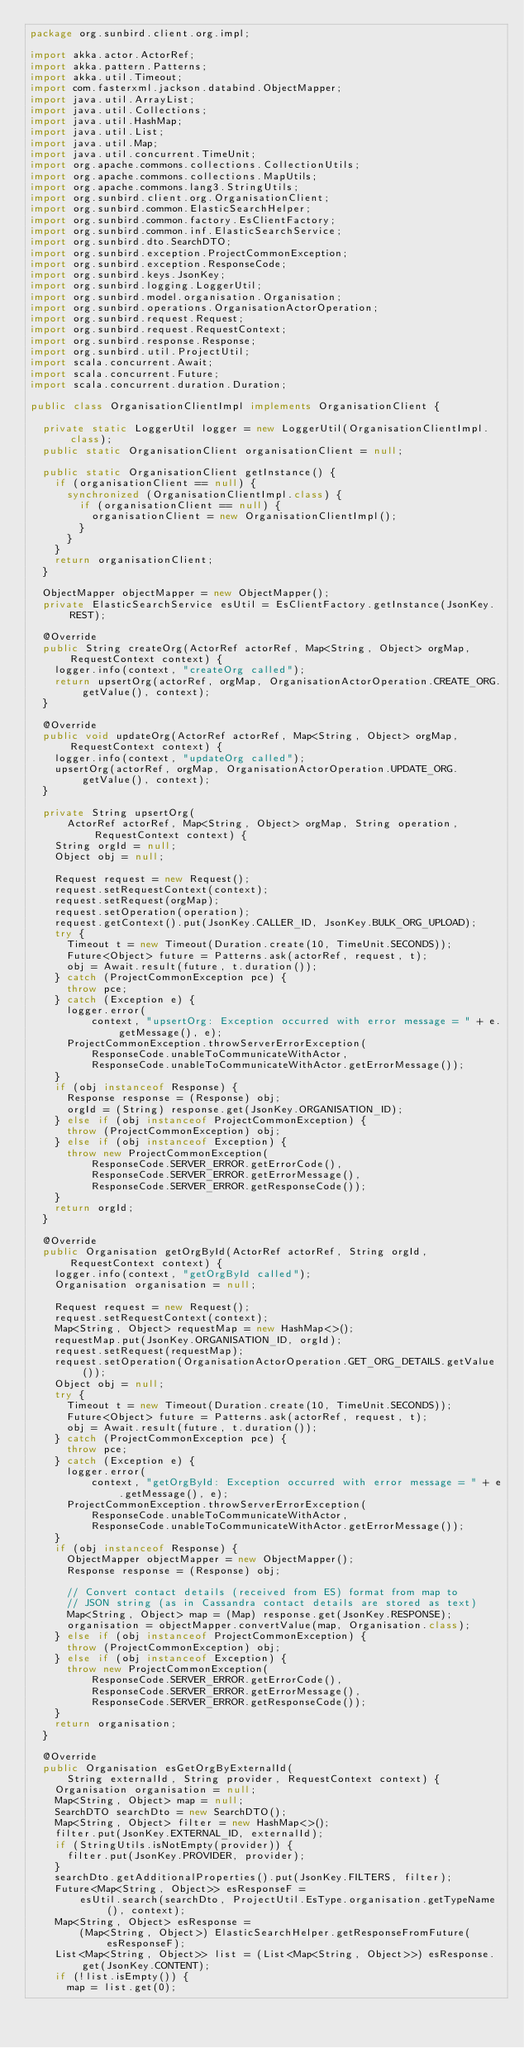<code> <loc_0><loc_0><loc_500><loc_500><_Java_>package org.sunbird.client.org.impl;

import akka.actor.ActorRef;
import akka.pattern.Patterns;
import akka.util.Timeout;
import com.fasterxml.jackson.databind.ObjectMapper;
import java.util.ArrayList;
import java.util.Collections;
import java.util.HashMap;
import java.util.List;
import java.util.Map;
import java.util.concurrent.TimeUnit;
import org.apache.commons.collections.CollectionUtils;
import org.apache.commons.collections.MapUtils;
import org.apache.commons.lang3.StringUtils;
import org.sunbird.client.org.OrganisationClient;
import org.sunbird.common.ElasticSearchHelper;
import org.sunbird.common.factory.EsClientFactory;
import org.sunbird.common.inf.ElasticSearchService;
import org.sunbird.dto.SearchDTO;
import org.sunbird.exception.ProjectCommonException;
import org.sunbird.exception.ResponseCode;
import org.sunbird.keys.JsonKey;
import org.sunbird.logging.LoggerUtil;
import org.sunbird.model.organisation.Organisation;
import org.sunbird.operations.OrganisationActorOperation;
import org.sunbird.request.Request;
import org.sunbird.request.RequestContext;
import org.sunbird.response.Response;
import org.sunbird.util.ProjectUtil;
import scala.concurrent.Await;
import scala.concurrent.Future;
import scala.concurrent.duration.Duration;

public class OrganisationClientImpl implements OrganisationClient {

  private static LoggerUtil logger = new LoggerUtil(OrganisationClientImpl.class);
  public static OrganisationClient organisationClient = null;

  public static OrganisationClient getInstance() {
    if (organisationClient == null) {
      synchronized (OrganisationClientImpl.class) {
        if (organisationClient == null) {
          organisationClient = new OrganisationClientImpl();
        }
      }
    }
    return organisationClient;
  }

  ObjectMapper objectMapper = new ObjectMapper();
  private ElasticSearchService esUtil = EsClientFactory.getInstance(JsonKey.REST);

  @Override
  public String createOrg(ActorRef actorRef, Map<String, Object> orgMap, RequestContext context) {
    logger.info(context, "createOrg called");
    return upsertOrg(actorRef, orgMap, OrganisationActorOperation.CREATE_ORG.getValue(), context);
  }

  @Override
  public void updateOrg(ActorRef actorRef, Map<String, Object> orgMap, RequestContext context) {
    logger.info(context, "updateOrg called");
    upsertOrg(actorRef, orgMap, OrganisationActorOperation.UPDATE_ORG.getValue(), context);
  }

  private String upsertOrg(
      ActorRef actorRef, Map<String, Object> orgMap, String operation, RequestContext context) {
    String orgId = null;
    Object obj = null;

    Request request = new Request();
    request.setRequestContext(context);
    request.setRequest(orgMap);
    request.setOperation(operation);
    request.getContext().put(JsonKey.CALLER_ID, JsonKey.BULK_ORG_UPLOAD);
    try {
      Timeout t = new Timeout(Duration.create(10, TimeUnit.SECONDS));
      Future<Object> future = Patterns.ask(actorRef, request, t);
      obj = Await.result(future, t.duration());
    } catch (ProjectCommonException pce) {
      throw pce;
    } catch (Exception e) {
      logger.error(
          context, "upsertOrg: Exception occurred with error message = " + e.getMessage(), e);
      ProjectCommonException.throwServerErrorException(
          ResponseCode.unableToCommunicateWithActor,
          ResponseCode.unableToCommunicateWithActor.getErrorMessage());
    }
    if (obj instanceof Response) {
      Response response = (Response) obj;
      orgId = (String) response.get(JsonKey.ORGANISATION_ID);
    } else if (obj instanceof ProjectCommonException) {
      throw (ProjectCommonException) obj;
    } else if (obj instanceof Exception) {
      throw new ProjectCommonException(
          ResponseCode.SERVER_ERROR.getErrorCode(),
          ResponseCode.SERVER_ERROR.getErrorMessage(),
          ResponseCode.SERVER_ERROR.getResponseCode());
    }
    return orgId;
  }

  @Override
  public Organisation getOrgById(ActorRef actorRef, String orgId, RequestContext context) {
    logger.info(context, "getOrgById called");
    Organisation organisation = null;

    Request request = new Request();
    request.setRequestContext(context);
    Map<String, Object> requestMap = new HashMap<>();
    requestMap.put(JsonKey.ORGANISATION_ID, orgId);
    request.setRequest(requestMap);
    request.setOperation(OrganisationActorOperation.GET_ORG_DETAILS.getValue());
    Object obj = null;
    try {
      Timeout t = new Timeout(Duration.create(10, TimeUnit.SECONDS));
      Future<Object> future = Patterns.ask(actorRef, request, t);
      obj = Await.result(future, t.duration());
    } catch (ProjectCommonException pce) {
      throw pce;
    } catch (Exception e) {
      logger.error(
          context, "getOrgById: Exception occurred with error message = " + e.getMessage(), e);
      ProjectCommonException.throwServerErrorException(
          ResponseCode.unableToCommunicateWithActor,
          ResponseCode.unableToCommunicateWithActor.getErrorMessage());
    }
    if (obj instanceof Response) {
      ObjectMapper objectMapper = new ObjectMapper();
      Response response = (Response) obj;

      // Convert contact details (received from ES) format from map to
      // JSON string (as in Cassandra contact details are stored as text)
      Map<String, Object> map = (Map) response.get(JsonKey.RESPONSE);
      organisation = objectMapper.convertValue(map, Organisation.class);
    } else if (obj instanceof ProjectCommonException) {
      throw (ProjectCommonException) obj;
    } else if (obj instanceof Exception) {
      throw new ProjectCommonException(
          ResponseCode.SERVER_ERROR.getErrorCode(),
          ResponseCode.SERVER_ERROR.getErrorMessage(),
          ResponseCode.SERVER_ERROR.getResponseCode());
    }
    return organisation;
  }

  @Override
  public Organisation esGetOrgByExternalId(
      String externalId, String provider, RequestContext context) {
    Organisation organisation = null;
    Map<String, Object> map = null;
    SearchDTO searchDto = new SearchDTO();
    Map<String, Object> filter = new HashMap<>();
    filter.put(JsonKey.EXTERNAL_ID, externalId);
    if (StringUtils.isNotEmpty(provider)) {
      filter.put(JsonKey.PROVIDER, provider);
    }
    searchDto.getAdditionalProperties().put(JsonKey.FILTERS, filter);
    Future<Map<String, Object>> esResponseF =
        esUtil.search(searchDto, ProjectUtil.EsType.organisation.getTypeName(), context);
    Map<String, Object> esResponse =
        (Map<String, Object>) ElasticSearchHelper.getResponseFromFuture(esResponseF);
    List<Map<String, Object>> list = (List<Map<String, Object>>) esResponse.get(JsonKey.CONTENT);
    if (!list.isEmpty()) {
      map = list.get(0);</code> 